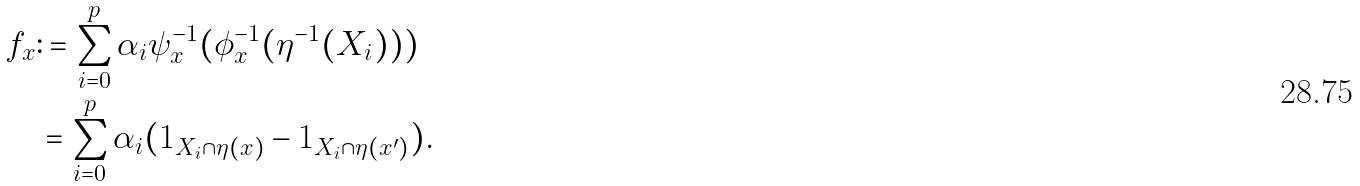Convert formula to latex. <formula><loc_0><loc_0><loc_500><loc_500>f _ { x } & \colon = \sum _ { i = 0 } ^ { p } \alpha _ { i } \psi _ { x } ^ { - 1 } ( \phi _ { x } ^ { - 1 } ( \eta ^ { - 1 } ( X _ { i } ) ) ) \\ & = \sum _ { i = 0 } ^ { p } \alpha _ { i } ( 1 _ { X _ { i } \cap \eta ( x ) } - 1 _ { X _ { i } \cap \eta ( x ^ { \prime } ) } ) .</formula> 